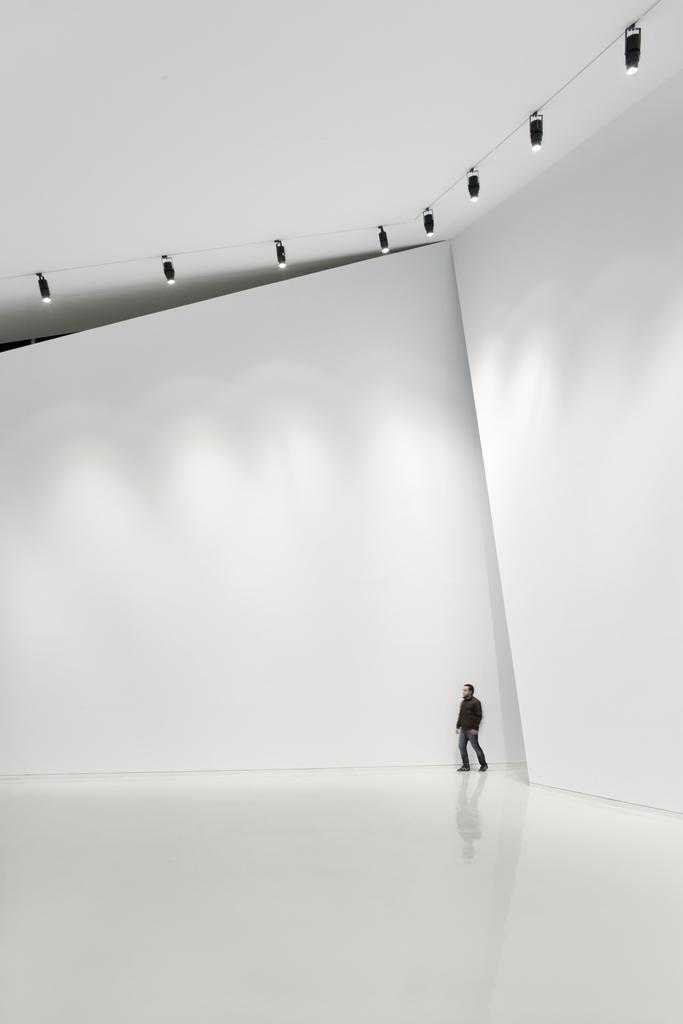What type of structure can be seen in the image? There is a big wall in the image, which suggests a building or enclosed space. What is above the wall in the image? There is a roof in the image. What is below the wall in the image? There is a floor in the image. Can you describe the man in the image? There is a man present in the image, wearing a black color shirt. What can be seen on the roof in the image? There are lights on the roof in the image. What type of bells can be heard ringing in the image? There are no bells present in the image, and therefore no sound can be heard. What time of day is it in the image? The image does not provide any information about the time of day. 